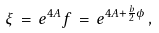<formula> <loc_0><loc_0><loc_500><loc_500>\xi \, = \, e ^ { 4 A } f \, = \, e ^ { 4 A + \frac { b } { 2 } \phi } \, ,</formula> 